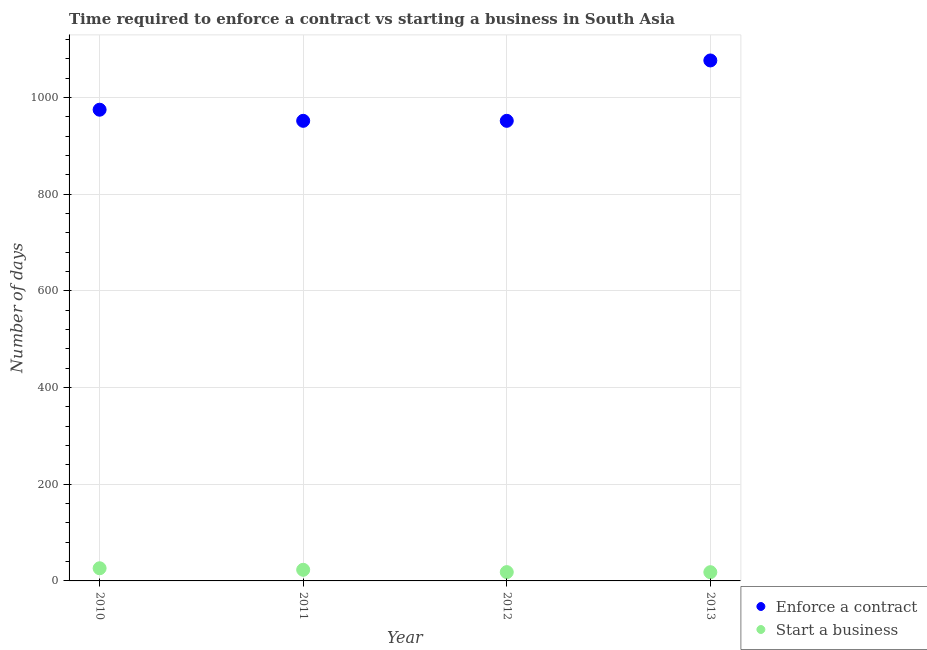What is the number of days to enforece a contract in 2010?
Give a very brief answer. 975. Across all years, what is the maximum number of days to start a business?
Provide a short and direct response. 26.2. Across all years, what is the minimum number of days to enforece a contract?
Make the answer very short. 952. In which year was the number of days to start a business minimum?
Provide a short and direct response. 2013. What is the total number of days to enforece a contract in the graph?
Make the answer very short. 3955.9. What is the difference between the number of days to start a business in 2010 and that in 2012?
Give a very brief answer. 8. What is the difference between the number of days to enforece a contract in 2011 and the number of days to start a business in 2013?
Provide a short and direct response. 933.94. What is the average number of days to enforece a contract per year?
Keep it short and to the point. 988.98. In the year 2013, what is the difference between the number of days to start a business and number of days to enforece a contract?
Ensure brevity in your answer.  -1058.84. What is the ratio of the number of days to start a business in 2010 to that in 2013?
Your answer should be very brief. 1.45. Is the number of days to start a business in 2010 less than that in 2011?
Provide a succinct answer. No. What is the difference between the highest and the second highest number of days to start a business?
Give a very brief answer. 3.2. What is the difference between the highest and the lowest number of days to enforece a contract?
Provide a short and direct response. 124.9. Does the number of days to enforece a contract monotonically increase over the years?
Ensure brevity in your answer.  No. How many dotlines are there?
Make the answer very short. 2. How many years are there in the graph?
Give a very brief answer. 4. What is the difference between two consecutive major ticks on the Y-axis?
Offer a very short reply. 200. Are the values on the major ticks of Y-axis written in scientific E-notation?
Your answer should be compact. No. Does the graph contain any zero values?
Offer a very short reply. No. What is the title of the graph?
Offer a very short reply. Time required to enforce a contract vs starting a business in South Asia. Does "Lowest 10% of population" appear as one of the legend labels in the graph?
Your answer should be compact. No. What is the label or title of the X-axis?
Ensure brevity in your answer.  Year. What is the label or title of the Y-axis?
Give a very brief answer. Number of days. What is the Number of days of Enforce a contract in 2010?
Offer a very short reply. 975. What is the Number of days of Start a business in 2010?
Provide a succinct answer. 26.2. What is the Number of days in Enforce a contract in 2011?
Offer a very short reply. 952. What is the Number of days of Start a business in 2011?
Your answer should be compact. 23. What is the Number of days of Enforce a contract in 2012?
Offer a terse response. 952. What is the Number of days of Enforce a contract in 2013?
Give a very brief answer. 1076.9. What is the Number of days of Start a business in 2013?
Give a very brief answer. 18.06. Across all years, what is the maximum Number of days in Enforce a contract?
Ensure brevity in your answer.  1076.9. Across all years, what is the maximum Number of days in Start a business?
Offer a terse response. 26.2. Across all years, what is the minimum Number of days in Enforce a contract?
Your answer should be compact. 952. Across all years, what is the minimum Number of days of Start a business?
Your answer should be very brief. 18.06. What is the total Number of days of Enforce a contract in the graph?
Offer a terse response. 3955.9. What is the total Number of days of Start a business in the graph?
Make the answer very short. 85.46. What is the difference between the Number of days in Enforce a contract in 2010 and that in 2011?
Your answer should be compact. 23. What is the difference between the Number of days in Start a business in 2010 and that in 2011?
Make the answer very short. 3.2. What is the difference between the Number of days in Enforce a contract in 2010 and that in 2012?
Your answer should be compact. 23. What is the difference between the Number of days of Enforce a contract in 2010 and that in 2013?
Offer a very short reply. -101.9. What is the difference between the Number of days in Start a business in 2010 and that in 2013?
Your answer should be very brief. 8.14. What is the difference between the Number of days in Enforce a contract in 2011 and that in 2012?
Ensure brevity in your answer.  0. What is the difference between the Number of days in Enforce a contract in 2011 and that in 2013?
Your answer should be very brief. -124.9. What is the difference between the Number of days in Start a business in 2011 and that in 2013?
Offer a very short reply. 4.94. What is the difference between the Number of days of Enforce a contract in 2012 and that in 2013?
Make the answer very short. -124.9. What is the difference between the Number of days in Start a business in 2012 and that in 2013?
Make the answer very short. 0.14. What is the difference between the Number of days of Enforce a contract in 2010 and the Number of days of Start a business in 2011?
Provide a short and direct response. 952. What is the difference between the Number of days of Enforce a contract in 2010 and the Number of days of Start a business in 2012?
Offer a very short reply. 956.8. What is the difference between the Number of days in Enforce a contract in 2010 and the Number of days in Start a business in 2013?
Provide a short and direct response. 956.94. What is the difference between the Number of days in Enforce a contract in 2011 and the Number of days in Start a business in 2012?
Offer a very short reply. 933.8. What is the difference between the Number of days of Enforce a contract in 2011 and the Number of days of Start a business in 2013?
Your response must be concise. 933.94. What is the difference between the Number of days in Enforce a contract in 2012 and the Number of days in Start a business in 2013?
Your answer should be compact. 933.94. What is the average Number of days in Enforce a contract per year?
Provide a succinct answer. 988.98. What is the average Number of days in Start a business per year?
Keep it short and to the point. 21.37. In the year 2010, what is the difference between the Number of days of Enforce a contract and Number of days of Start a business?
Provide a succinct answer. 948.8. In the year 2011, what is the difference between the Number of days of Enforce a contract and Number of days of Start a business?
Your response must be concise. 929. In the year 2012, what is the difference between the Number of days in Enforce a contract and Number of days in Start a business?
Your response must be concise. 933.8. In the year 2013, what is the difference between the Number of days of Enforce a contract and Number of days of Start a business?
Offer a very short reply. 1058.84. What is the ratio of the Number of days of Enforce a contract in 2010 to that in 2011?
Provide a short and direct response. 1.02. What is the ratio of the Number of days in Start a business in 2010 to that in 2011?
Make the answer very short. 1.14. What is the ratio of the Number of days of Enforce a contract in 2010 to that in 2012?
Give a very brief answer. 1.02. What is the ratio of the Number of days in Start a business in 2010 to that in 2012?
Provide a succinct answer. 1.44. What is the ratio of the Number of days in Enforce a contract in 2010 to that in 2013?
Ensure brevity in your answer.  0.91. What is the ratio of the Number of days in Start a business in 2010 to that in 2013?
Offer a very short reply. 1.45. What is the ratio of the Number of days of Enforce a contract in 2011 to that in 2012?
Ensure brevity in your answer.  1. What is the ratio of the Number of days in Start a business in 2011 to that in 2012?
Your response must be concise. 1.26. What is the ratio of the Number of days of Enforce a contract in 2011 to that in 2013?
Ensure brevity in your answer.  0.88. What is the ratio of the Number of days in Start a business in 2011 to that in 2013?
Offer a terse response. 1.27. What is the ratio of the Number of days of Enforce a contract in 2012 to that in 2013?
Your response must be concise. 0.88. What is the ratio of the Number of days of Start a business in 2012 to that in 2013?
Give a very brief answer. 1.01. What is the difference between the highest and the second highest Number of days in Enforce a contract?
Offer a terse response. 101.9. What is the difference between the highest and the second highest Number of days in Start a business?
Provide a short and direct response. 3.2. What is the difference between the highest and the lowest Number of days of Enforce a contract?
Keep it short and to the point. 124.9. What is the difference between the highest and the lowest Number of days of Start a business?
Your answer should be very brief. 8.14. 